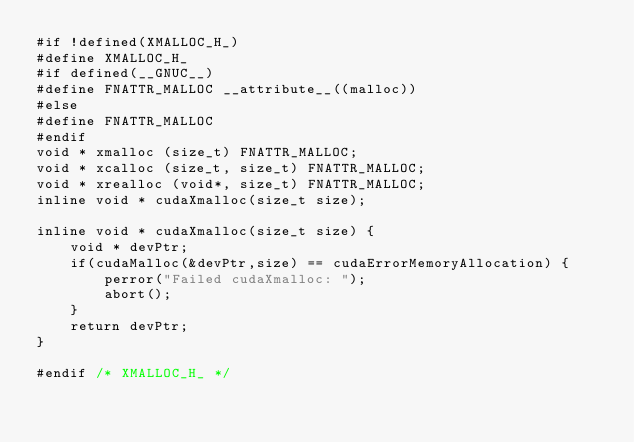Convert code to text. <code><loc_0><loc_0><loc_500><loc_500><_Cuda_>#if !defined(XMALLOC_H_)
#define XMALLOC_H_
#if defined(__GNUC__)
#define FNATTR_MALLOC __attribute__((malloc))
#else
#define FNATTR_MALLOC
#endif
void * xmalloc (size_t) FNATTR_MALLOC;
void * xcalloc (size_t, size_t) FNATTR_MALLOC;
void * xrealloc (void*, size_t) FNATTR_MALLOC;
inline void * cudaXmalloc(size_t size);

inline void * cudaXmalloc(size_t size) {
	void * devPtr;
	if(cudaMalloc(&devPtr,size) == cudaErrorMemoryAllocation) {
		perror("Failed cudaXmalloc: ");
		abort();
	}
	return devPtr;
} 

#endif /* XMALLOC_H_ */
</code> 